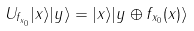<formula> <loc_0><loc_0><loc_500><loc_500>U _ { f _ { x _ { 0 } } } | x \rangle | y \rangle = | x \rangle | y \oplus f _ { x _ { 0 } } ( x ) \rangle</formula> 